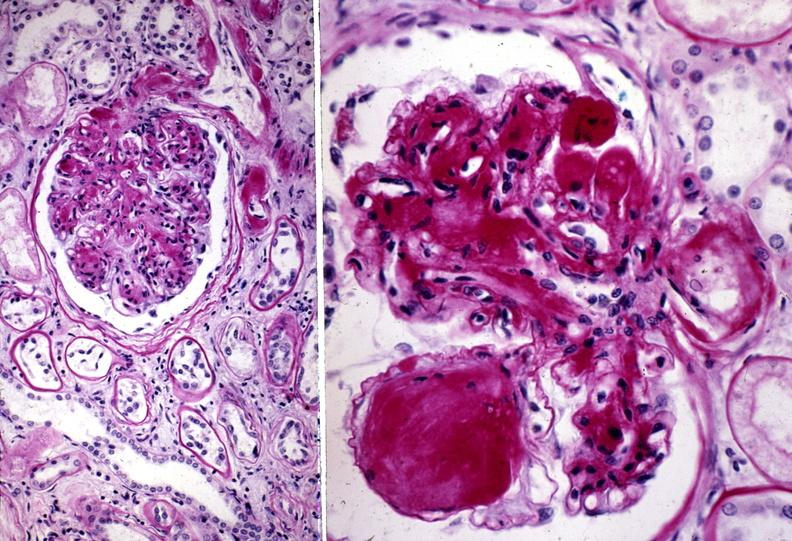does this image show kidney, diabetic glomerulosclerosis?
Answer the question using a single word or phrase. Yes 